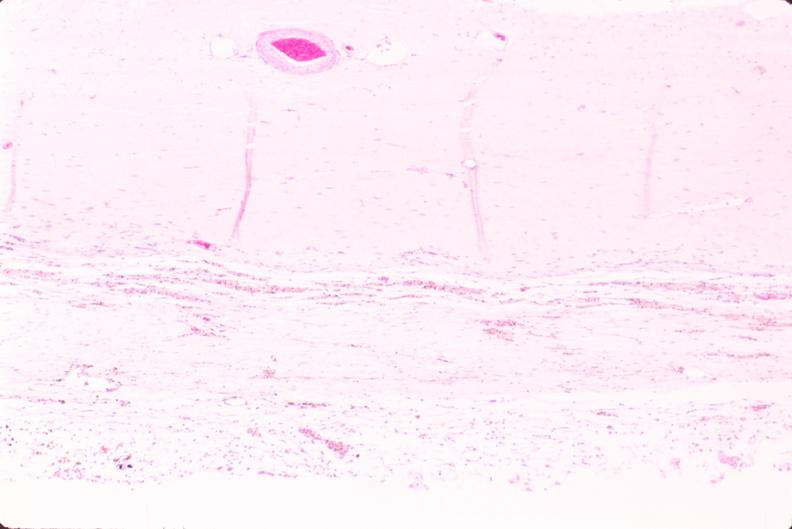why does this image show brain, infarct?
Answer the question using a single word or phrase. Due to ruptured saccular aneurysm and thrombosis of right middle cerebral artery 